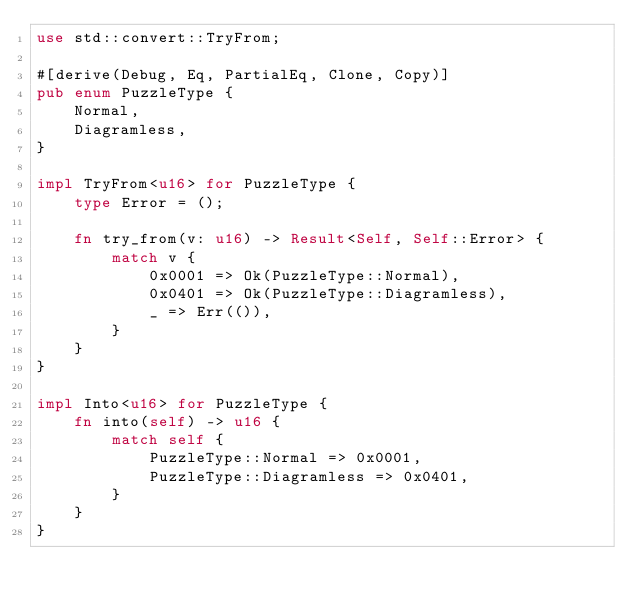Convert code to text. <code><loc_0><loc_0><loc_500><loc_500><_Rust_>use std::convert::TryFrom;

#[derive(Debug, Eq, PartialEq, Clone, Copy)]
pub enum PuzzleType {
    Normal,
    Diagramless,
}

impl TryFrom<u16> for PuzzleType {
    type Error = ();

    fn try_from(v: u16) -> Result<Self, Self::Error> {
        match v {
            0x0001 => Ok(PuzzleType::Normal),
            0x0401 => Ok(PuzzleType::Diagramless),
            _ => Err(()),
        }
    }
}

impl Into<u16> for PuzzleType {
    fn into(self) -> u16 {
        match self {
            PuzzleType::Normal => 0x0001,
            PuzzleType::Diagramless => 0x0401,
        }
    }
}
</code> 